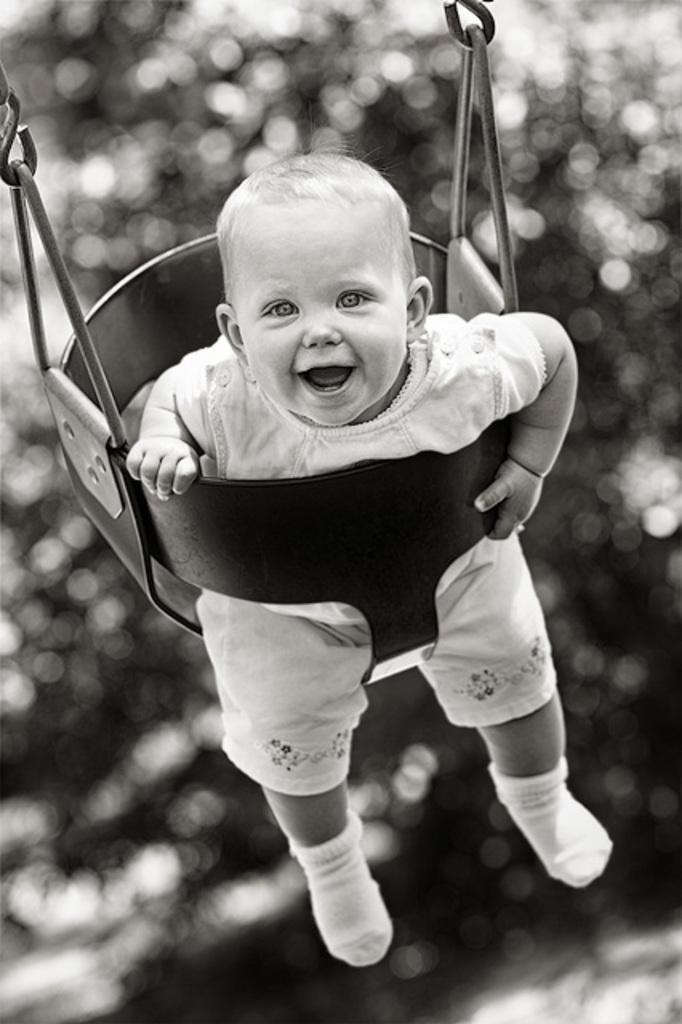In one or two sentences, can you explain what this image depicts? This picture is in black and white. The baby in white dress is sitting on the swing. He is smiling. Behind him, there are trees. It is blurred in the background. 